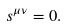<formula> <loc_0><loc_0><loc_500><loc_500>s ^ { \mu \nu } = 0 .</formula> 